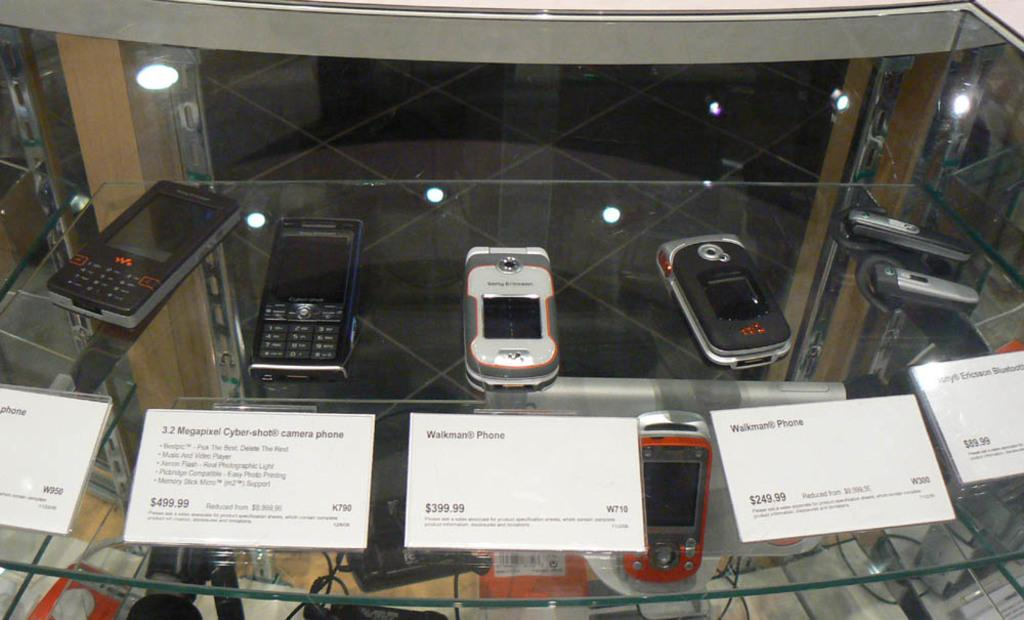Provide a one-sentence caption for the provided image. Different phones with prices are displayed including a Walkman phone. 